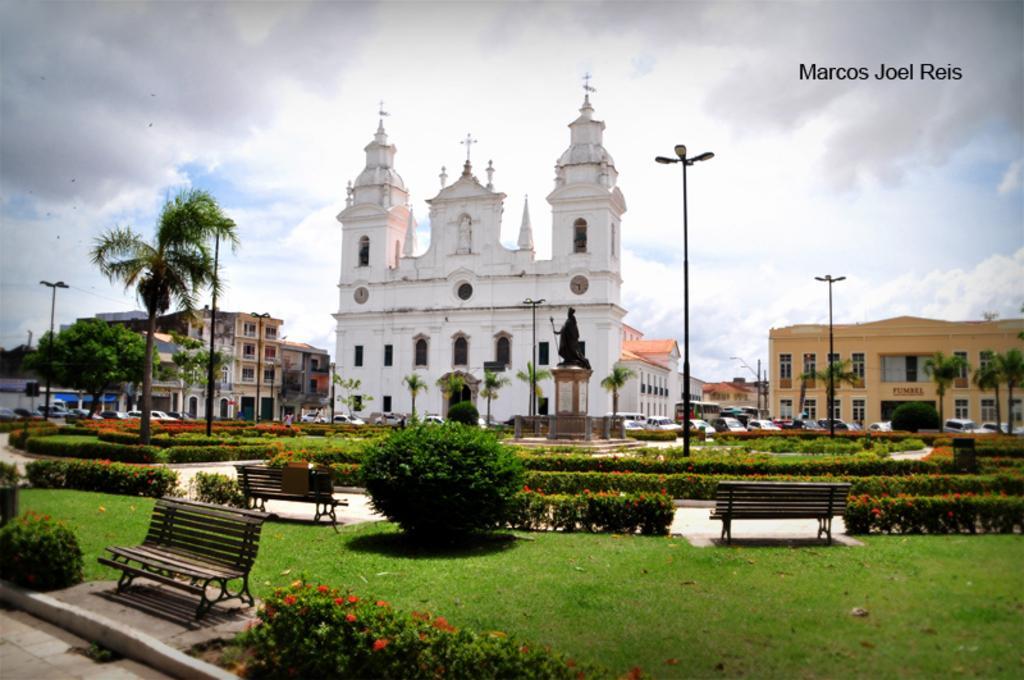In one or two sentences, can you explain what this image depicts? In this image we can see buildings, motor vehicles on the road, statue, pedestal, street poles, street lights, electric cables, trees, garden mazes, bushes, benches and sky with clouds. 